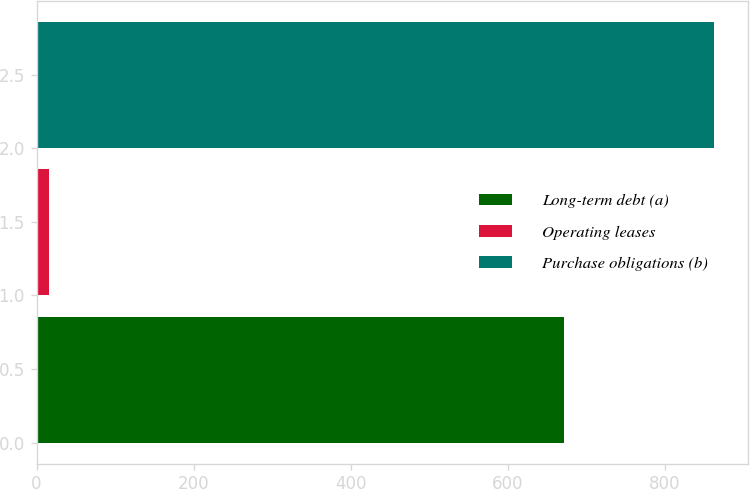Convert chart. <chart><loc_0><loc_0><loc_500><loc_500><bar_chart><fcel>Long-term debt (a)<fcel>Operating leases<fcel>Purchase obligations (b)<nl><fcel>672<fcel>16<fcel>863<nl></chart> 